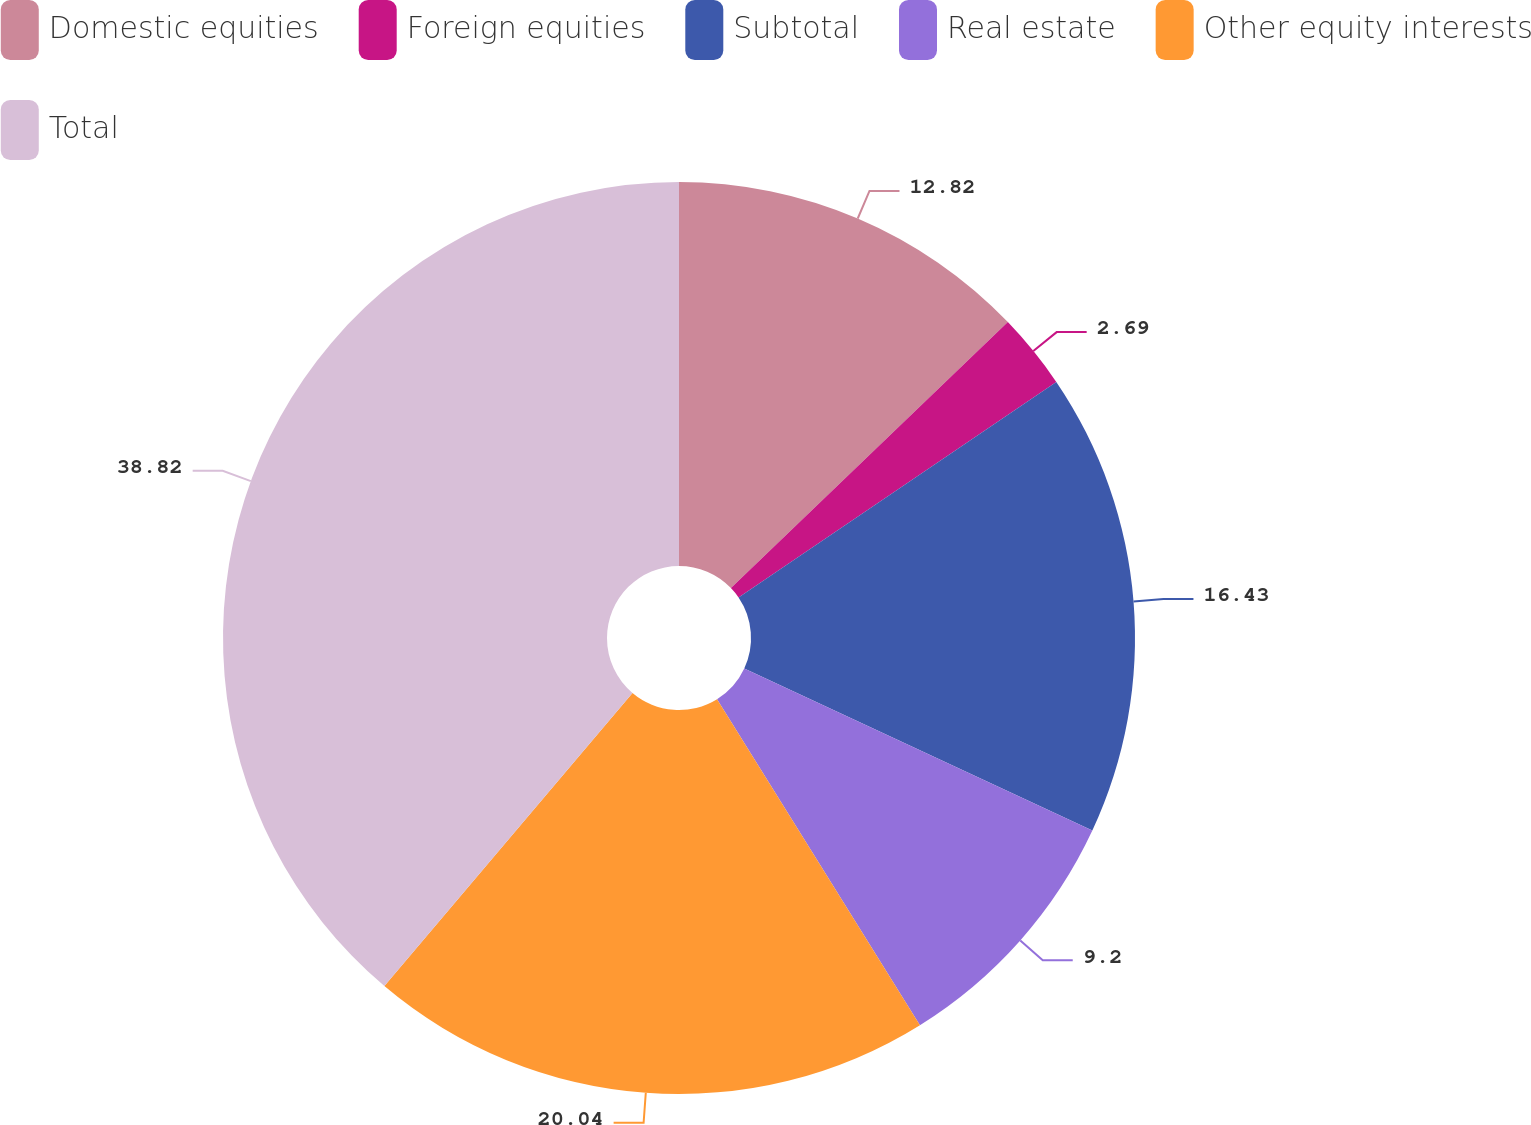Convert chart to OTSL. <chart><loc_0><loc_0><loc_500><loc_500><pie_chart><fcel>Domestic equities<fcel>Foreign equities<fcel>Subtotal<fcel>Real estate<fcel>Other equity interests<fcel>Total<nl><fcel>12.82%<fcel>2.69%<fcel>16.43%<fcel>9.2%<fcel>20.04%<fcel>38.82%<nl></chart> 